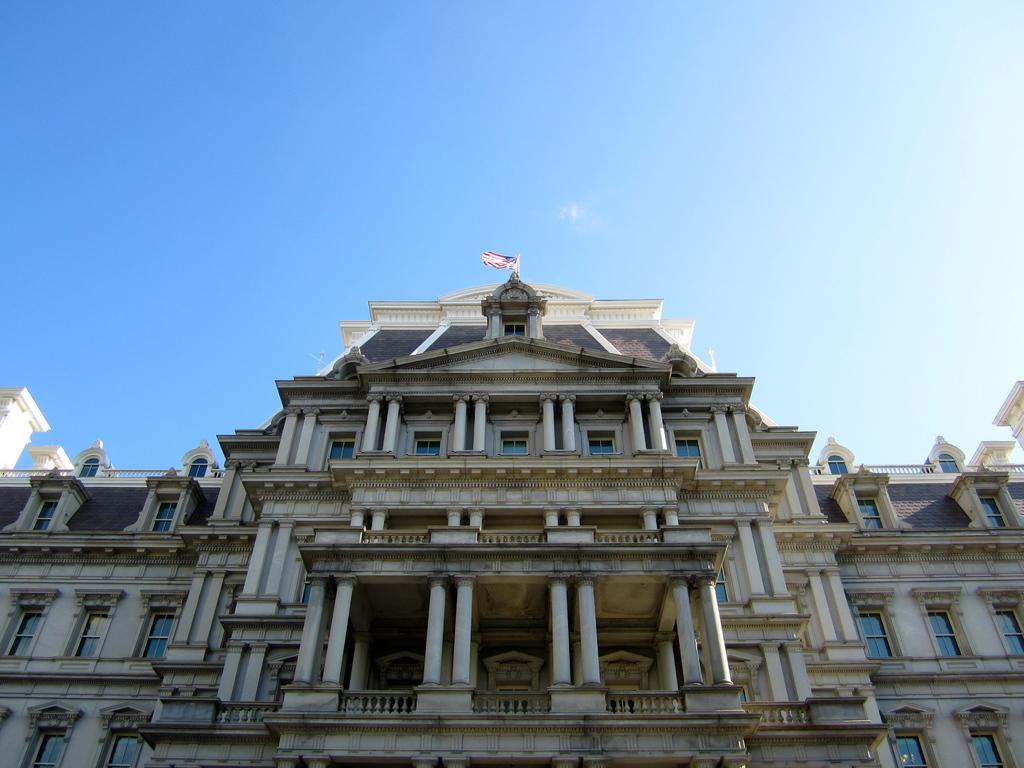What type of structure is present in the image? There is a building in the image. What feature of the building can be observed? The building has multiple windows. What additional element is present in the image? There is a flag in the image. What colors are present on the flag? The flag has white, red, and blue colors. What can be seen in the background of the image? The sky is visible in the background of the image. Is there a volcano erupting in the image? No, there is no volcano present in the image. What type of bucket is being used to collect water from the building? There is no bucket present in the image. 